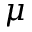Convert formula to latex. <formula><loc_0><loc_0><loc_500><loc_500>\mu</formula> 